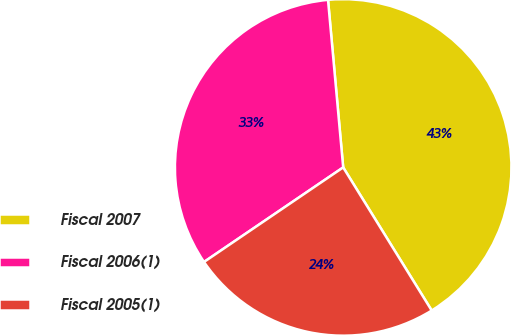Convert chart to OTSL. <chart><loc_0><loc_0><loc_500><loc_500><pie_chart><fcel>Fiscal 2007<fcel>Fiscal 2006(1)<fcel>Fiscal 2005(1)<nl><fcel>42.62%<fcel>33.06%<fcel>24.32%<nl></chart> 